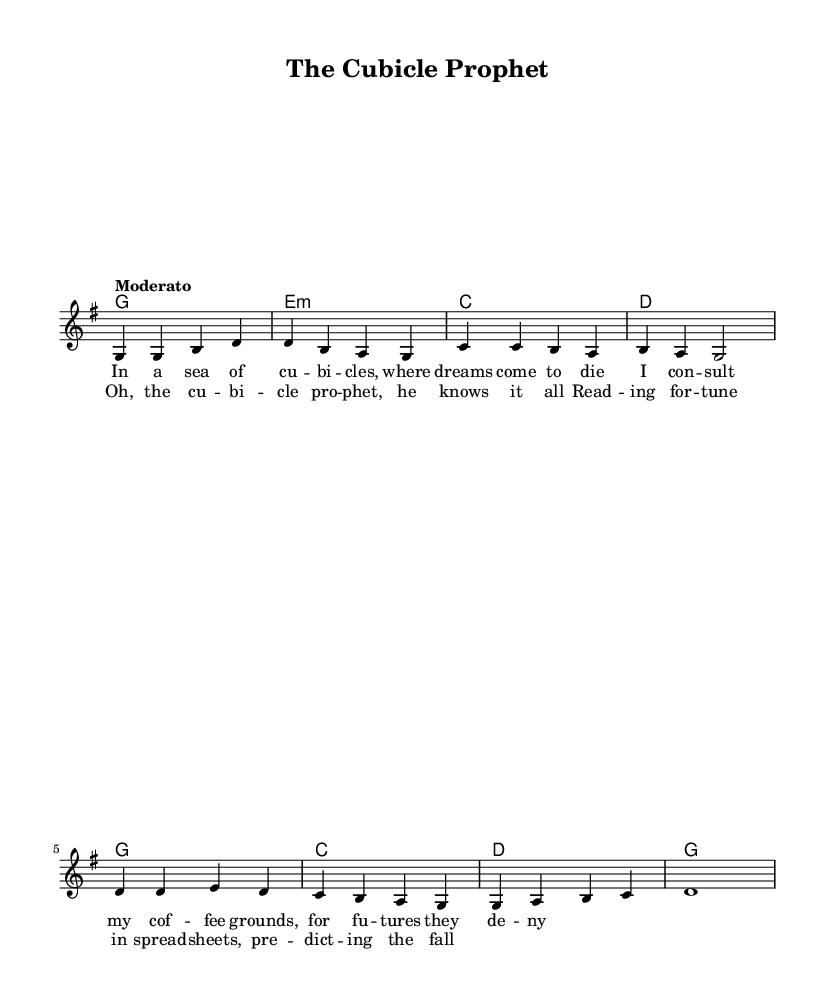What is the key signature of this music? The key signature is G major, which has one sharp (F#).
Answer: G major What is the time signature of this music? The time signature indicated is 4/4, meaning each measure contains four beats.
Answer: 4/4 What is the tempo marking of this piece? The tempo marking is "Moderato," which suggests a moderate speed for the performance.
Answer: Moderato How many lines of lyrics are provided in the verse? The verse contains four lines of lyrics, as structured in the sheet music.
Answer: Four lines What type of music is this, based on its lyrical content? The music is classified as a satirical folk ballad, reflecting on urban life and its absurdities through humorous lyrics.
Answer: Satirical folk ballad Which chord is played in the last measure? The last measure features the G major chord, supporting the ending of the chorus.
Answer: G How does the chorus connect with the verse in terms of melody? Both the verse and chorus follow similar melodic contours, but the chorus has distinct rhythmic patterns and varied phrasing.
Answer: Similar contours 